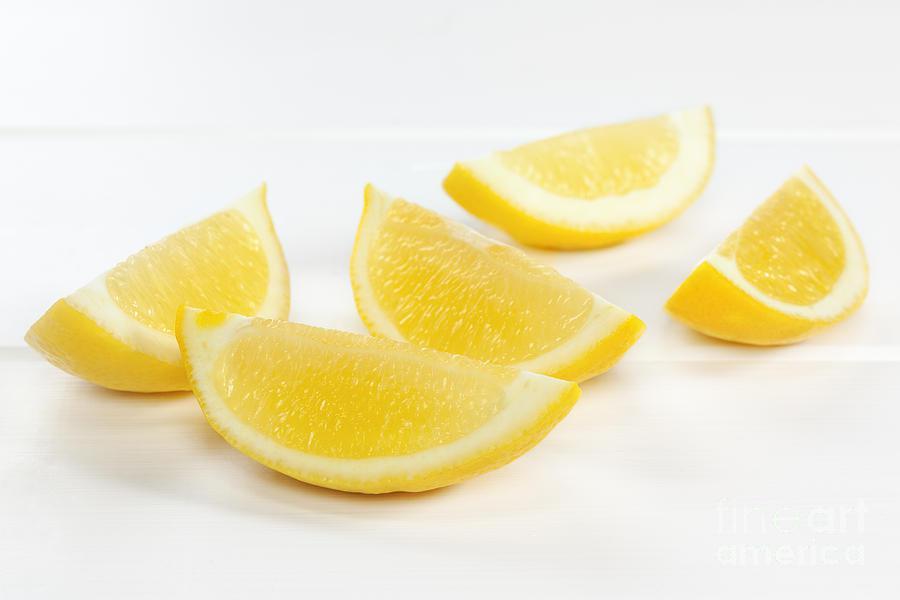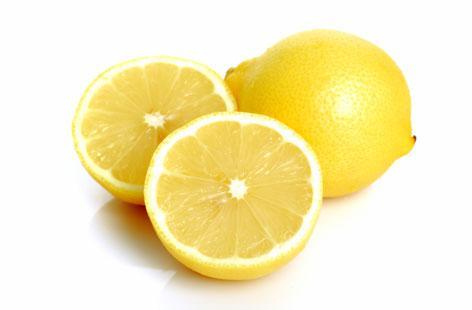The first image is the image on the left, the second image is the image on the right. Examine the images to the left and right. Is the description "One image includes whole and half lemons." accurate? Answer yes or no. Yes. 